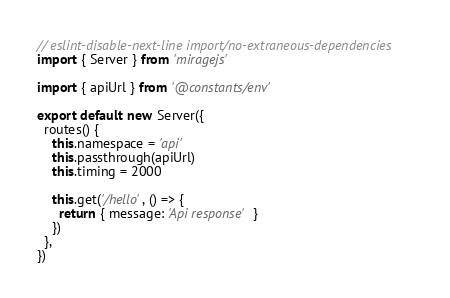<code> <loc_0><loc_0><loc_500><loc_500><_TypeScript_>// eslint-disable-next-line import/no-extraneous-dependencies
import { Server } from 'miragejs'

import { apiUrl } from '@constants/env'

export default new Server({
  routes() {
    this.namespace = 'api'
    this.passthrough(apiUrl)
    this.timing = 2000

    this.get('/hello', () => {
      return { message: 'Api response' }
    })
  },
})
</code> 